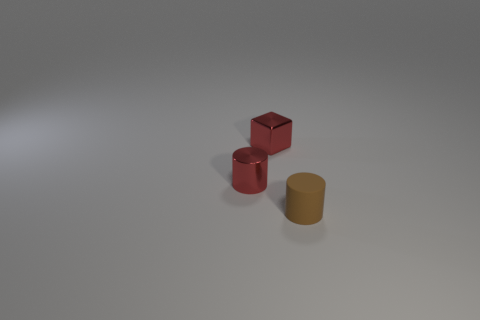Add 1 small metal cubes. How many objects exist? 4 Subtract all cylinders. How many objects are left? 1 Subtract 0 green cubes. How many objects are left? 3 Subtract all red cylinders. Subtract all small red things. How many objects are left? 0 Add 3 small brown rubber things. How many small brown rubber things are left? 4 Add 2 tiny green matte cubes. How many tiny green matte cubes exist? 2 